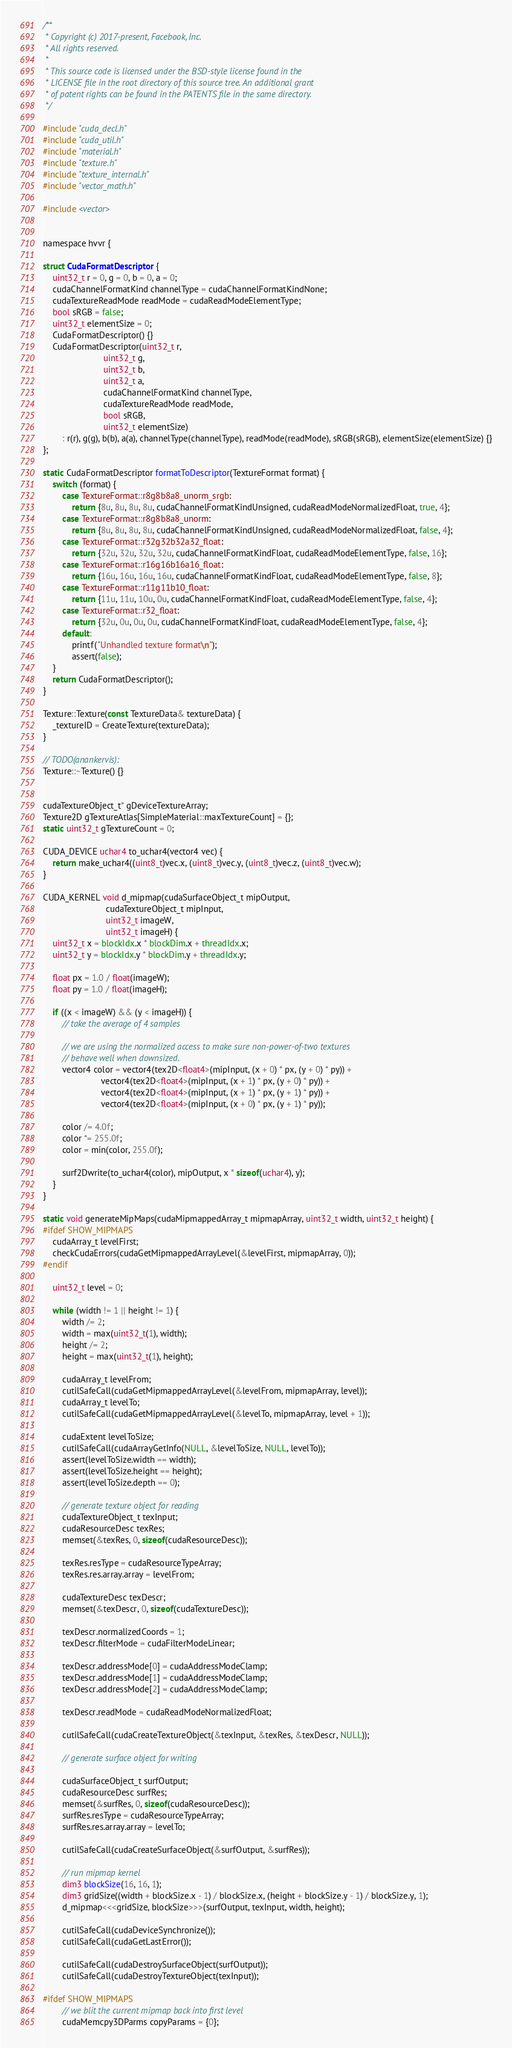Convert code to text. <code><loc_0><loc_0><loc_500><loc_500><_Cuda_>/**
 * Copyright (c) 2017-present, Facebook, Inc.
 * All rights reserved.
 *
 * This source code is licensed under the BSD-style license found in the
 * LICENSE file in the root directory of this source tree. An additional grant
 * of patent rights can be found in the PATENTS file in the same directory.
 */

#include "cuda_decl.h"
#include "cuda_util.h"
#include "material.h"
#include "texture.h"
#include "texture_internal.h"
#include "vector_math.h"

#include <vector>


namespace hvvr {

struct CudaFormatDescriptor {
    uint32_t r = 0, g = 0, b = 0, a = 0;
    cudaChannelFormatKind channelType = cudaChannelFormatKindNone;
    cudaTextureReadMode readMode = cudaReadModeElementType;
    bool sRGB = false;
    uint32_t elementSize = 0;
    CudaFormatDescriptor() {}
    CudaFormatDescriptor(uint32_t r,
                         uint32_t g,
                         uint32_t b,
                         uint32_t a,
                         cudaChannelFormatKind channelType,
                         cudaTextureReadMode readMode,
                         bool sRGB,
                         uint32_t elementSize)
        : r(r), g(g), b(b), a(a), channelType(channelType), readMode(readMode), sRGB(sRGB), elementSize(elementSize) {}
};

static CudaFormatDescriptor formatToDescriptor(TextureFormat format) {
    switch (format) {
        case TextureFormat::r8g8b8a8_unorm_srgb:
            return {8u, 8u, 8u, 8u, cudaChannelFormatKindUnsigned, cudaReadModeNormalizedFloat, true, 4};
        case TextureFormat::r8g8b8a8_unorm:
            return {8u, 8u, 8u, 8u, cudaChannelFormatKindUnsigned, cudaReadModeNormalizedFloat, false, 4};
        case TextureFormat::r32g32b32a32_float:
            return {32u, 32u, 32u, 32u, cudaChannelFormatKindFloat, cudaReadModeElementType, false, 16};
        case TextureFormat::r16g16b16a16_float:
            return {16u, 16u, 16u, 16u, cudaChannelFormatKindFloat, cudaReadModeElementType, false, 8};
        case TextureFormat::r11g11b10_float:
            return {11u, 11u, 10u, 0u, cudaChannelFormatKindFloat, cudaReadModeElementType, false, 4};
        case TextureFormat::r32_float:
            return {32u, 0u, 0u, 0u, cudaChannelFormatKindFloat, cudaReadModeElementType, false, 4};
        default:
            printf("Unhandled texture format\n");
            assert(false);
    }
    return CudaFormatDescriptor();
}

Texture::Texture(const TextureData& textureData) {
    _textureID = CreateTexture(textureData);
}

// TODO(anankervis):
Texture::~Texture() {}


cudaTextureObject_t* gDeviceTextureArray;
Texture2D gTextureAtlas[SimpleMaterial::maxTextureCount] = {};
static uint32_t gTextureCount = 0;

CUDA_DEVICE uchar4 to_uchar4(vector4 vec) {
    return make_uchar4((uint8_t)vec.x, (uint8_t)vec.y, (uint8_t)vec.z, (uint8_t)vec.w);
}

CUDA_KERNEL void d_mipmap(cudaSurfaceObject_t mipOutput,
                          cudaTextureObject_t mipInput,
                          uint32_t imageW,
                          uint32_t imageH) {
    uint32_t x = blockIdx.x * blockDim.x + threadIdx.x;
    uint32_t y = blockIdx.y * blockDim.y + threadIdx.y;

    float px = 1.0 / float(imageW);
    float py = 1.0 / float(imageH);

    if ((x < imageW) && (y < imageH)) {
        // take the average of 4 samples

        // we are using the normalized access to make sure non-power-of-two textures
        // behave well when downsized.
        vector4 color = vector4(tex2D<float4>(mipInput, (x + 0) * px, (y + 0) * py)) +
                        vector4(tex2D<float4>(mipInput, (x + 1) * px, (y + 0) * py)) +
                        vector4(tex2D<float4>(mipInput, (x + 1) * px, (y + 1) * py)) +
                        vector4(tex2D<float4>(mipInput, (x + 0) * px, (y + 1) * py));

        color /= 4.0f;
        color *= 255.0f;
        color = min(color, 255.0f);

        surf2Dwrite(to_uchar4(color), mipOutput, x * sizeof(uchar4), y);
    }
}

static void generateMipMaps(cudaMipmappedArray_t mipmapArray, uint32_t width, uint32_t height) {
#ifdef SHOW_MIPMAPS
    cudaArray_t levelFirst;
    checkCudaErrors(cudaGetMipmappedArrayLevel(&levelFirst, mipmapArray, 0));
#endif

    uint32_t level = 0;

    while (width != 1 || height != 1) {
        width /= 2;
        width = max(uint32_t(1), width);
        height /= 2;
        height = max(uint32_t(1), height);

        cudaArray_t levelFrom;
        cutilSafeCall(cudaGetMipmappedArrayLevel(&levelFrom, mipmapArray, level));
        cudaArray_t levelTo;
        cutilSafeCall(cudaGetMipmappedArrayLevel(&levelTo, mipmapArray, level + 1));

        cudaExtent levelToSize;
        cutilSafeCall(cudaArrayGetInfo(NULL, &levelToSize, NULL, levelTo));
        assert(levelToSize.width == width);
        assert(levelToSize.height == height);
        assert(levelToSize.depth == 0);

        // generate texture object for reading
        cudaTextureObject_t texInput;
        cudaResourceDesc texRes;
        memset(&texRes, 0, sizeof(cudaResourceDesc));

        texRes.resType = cudaResourceTypeArray;
        texRes.res.array.array = levelFrom;

        cudaTextureDesc texDescr;
        memset(&texDescr, 0, sizeof(cudaTextureDesc));

        texDescr.normalizedCoords = 1;
        texDescr.filterMode = cudaFilterModeLinear;

        texDescr.addressMode[0] = cudaAddressModeClamp;
        texDescr.addressMode[1] = cudaAddressModeClamp;
        texDescr.addressMode[2] = cudaAddressModeClamp;

        texDescr.readMode = cudaReadModeNormalizedFloat;

        cutilSafeCall(cudaCreateTextureObject(&texInput, &texRes, &texDescr, NULL));

        // generate surface object for writing

        cudaSurfaceObject_t surfOutput;
        cudaResourceDesc surfRes;
        memset(&surfRes, 0, sizeof(cudaResourceDesc));
        surfRes.resType = cudaResourceTypeArray;
        surfRes.res.array.array = levelTo;

        cutilSafeCall(cudaCreateSurfaceObject(&surfOutput, &surfRes));

        // run mipmap kernel
        dim3 blockSize(16, 16, 1);
        dim3 gridSize((width + blockSize.x - 1) / blockSize.x, (height + blockSize.y - 1) / blockSize.y, 1);
        d_mipmap<<<gridSize, blockSize>>>(surfOutput, texInput, width, height);

        cutilSafeCall(cudaDeviceSynchronize());
        cutilSafeCall(cudaGetLastError());

        cutilSafeCall(cudaDestroySurfaceObject(surfOutput));
        cutilSafeCall(cudaDestroyTextureObject(texInput));

#ifdef SHOW_MIPMAPS
        // we blit the current mipmap back into first level
        cudaMemcpy3DParms copyParams = {0};</code> 